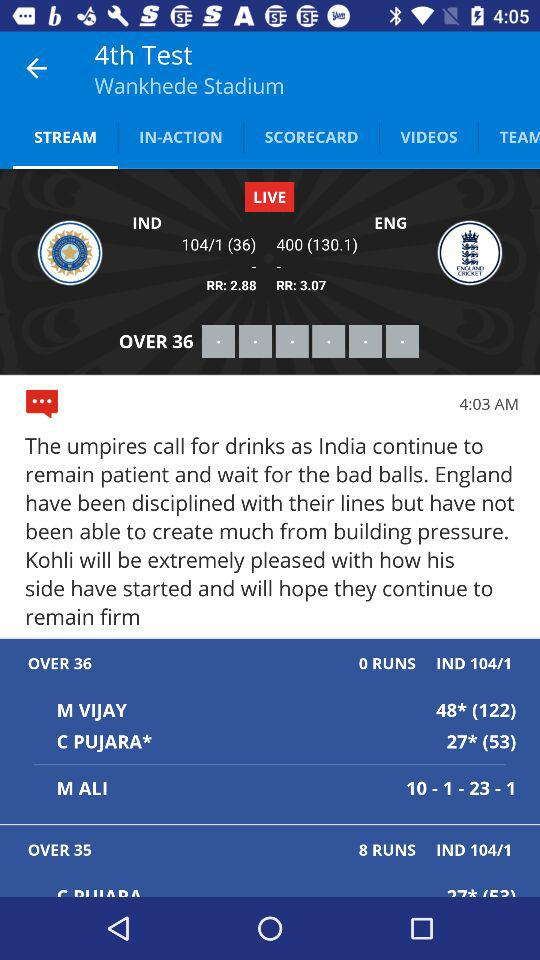How many runs has India scored in the last 2 overs?
Answer the question using a single word or phrase. 8 